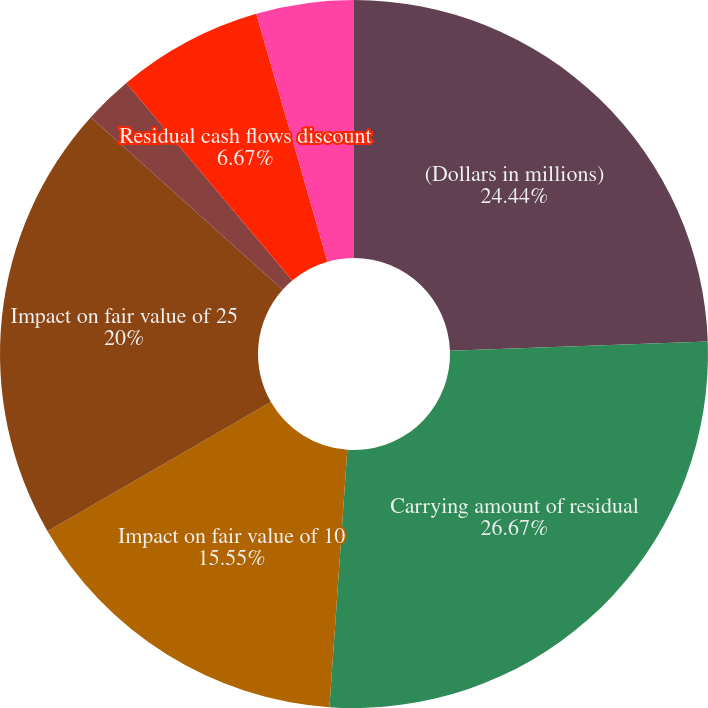<chart> <loc_0><loc_0><loc_500><loc_500><pie_chart><fcel>(Dollars in millions)<fcel>Carrying amount of residual<fcel>Weighted average life to call<fcel>Impact on fair value of 10<fcel>Impact on fair value of 25<fcel>Weighted average expected<fcel>Residual cash flows discount<fcel>Impact on fair value of 100<nl><fcel>24.44%<fcel>26.66%<fcel>0.0%<fcel>15.55%<fcel>20.0%<fcel>2.22%<fcel>6.67%<fcel>4.45%<nl></chart> 